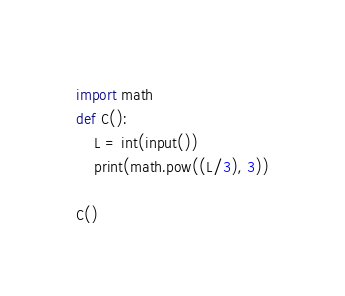Convert code to text. <code><loc_0><loc_0><loc_500><loc_500><_Python_>import math
def C():
    L = int(input())
    print(math.pow((L/3), 3))
    
C()</code> 